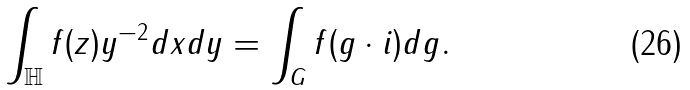Convert formula to latex. <formula><loc_0><loc_0><loc_500><loc_500>\int _ { \mathbb { H } } f ( z ) y ^ { - 2 } d x d y = \int _ { G } f ( g \cdot i ) d g .</formula> 